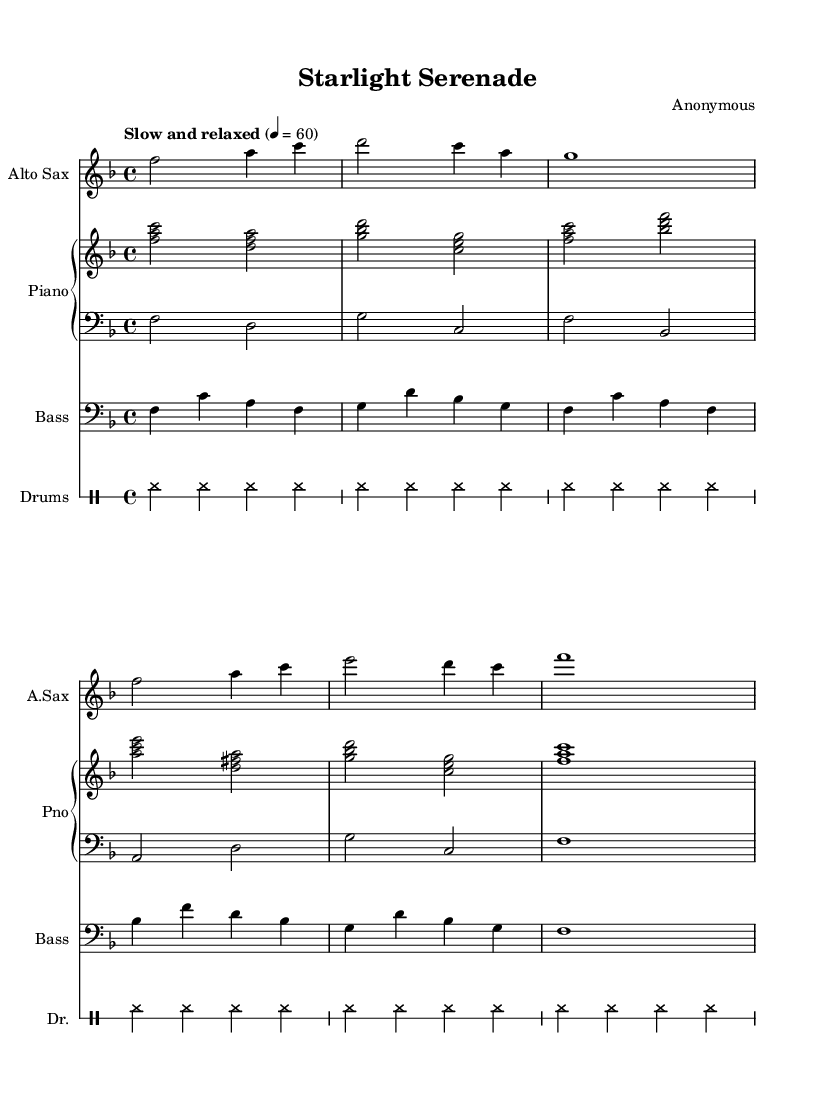What is the key signature of this music? The key signature is F major, which has one flat (B flat). We can identify the key signature by looking at the beginning of the sheet music, where the flat symbol appears on the B line.
Answer: F major What is the time signature of this music? The time signature is 4/4, which is indicated at the beginning of the score. This means there are four beats in each measure and the quarter note gets one beat.
Answer: 4/4 What is the tempo marking for this piece? The tempo marking is "Slow and relaxed," indicated just above the staff. This marks the intended speed and feel for the performance.
Answer: Slow and relaxed How many measures are in the saxophone part? There are eight measures in the saxophone part. Counting each vertical line between the notes helps us determine the number of measures present in the part.
Answer: Eight What is the highest note played by the piano in the right hand? The highest note played in the piano right hand part is A. By identifying the note heads in the right-hand staff, we see A is the topmost note in the specified range of the piece.
Answer: A Which instruments are featured in this score? The featured instruments are Alto Sax, Piano, Bass, and Drums. Each instrument is designated at the beginning of its staff in the score.
Answer: Alto Sax, Piano, Bass, Drums 